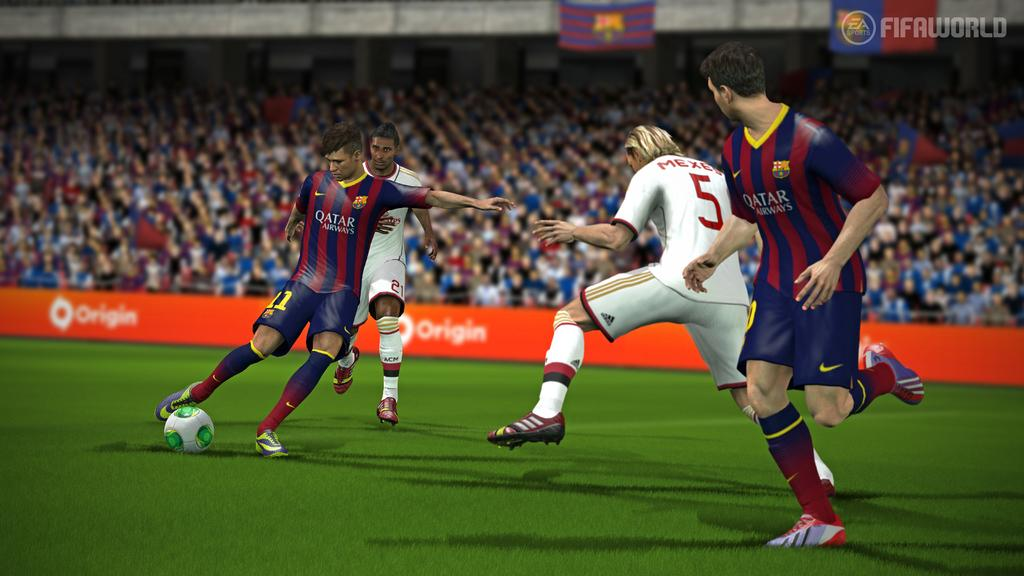<image>
Offer a succinct explanation of the picture presented. A soccer player with the words Quatar airways on his shirt is about to kick a ball 